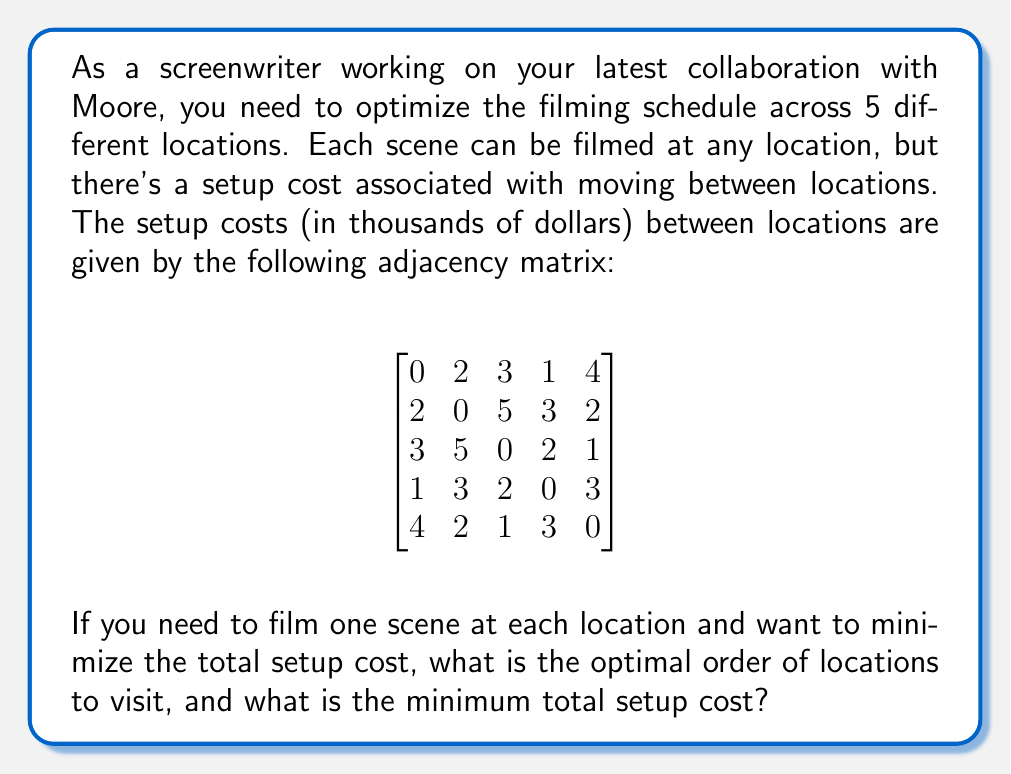Can you solve this math problem? This problem is an instance of the Traveling Salesman Problem (TSP) in graph theory. To solve it:

1) First, we need to recognize that this is a complete graph with 5 vertices (locations) where the edge weights represent the setup costs.

2) For a graph with 5 vertices, there are $(5-1)! = 24$ possible cycles (excluding rotations and reverse order).

3) We need to find the cycle with the minimum total weight. One way to do this is to use the brute-force method and check all possibilities:

   (1,2,3,4,5,1): 2 + 5 + 2 + 3 + 4 = 16
   (1,2,3,5,4,1): 2 + 5 + 1 + 3 + 1 = 12
   (1,2,4,3,5,1): 2 + 3 + 2 + 1 + 4 = 12
   (1,2,4,5,3,1): 2 + 3 + 3 + 1 + 3 = 12
   (1,2,5,3,4,1): 2 + 2 + 1 + 2 + 1 = 8
   (1,2,5,4,3,1): 2 + 2 + 3 + 2 + 3 = 12
   ...

4) After checking all possibilities, we find that the minimum cost cycle is (1,2,5,3,4,1) or its reverse (1,4,3,5,2,1), both with a total cost of 8.

5) This means the optimal order to visit the locations is either 1 → 2 → 5 → 3 → 4 → 1 or 1 → 4 → 3 → 5 → 2 → 1.

6) The minimum total setup cost is 8 thousand dollars.
Answer: The optimal order of locations to visit is either 1 → 2 → 5 → 3 → 4 → 1 or 1 → 4 → 3 → 5 → 2 → 1, and the minimum total setup cost is $8,000. 